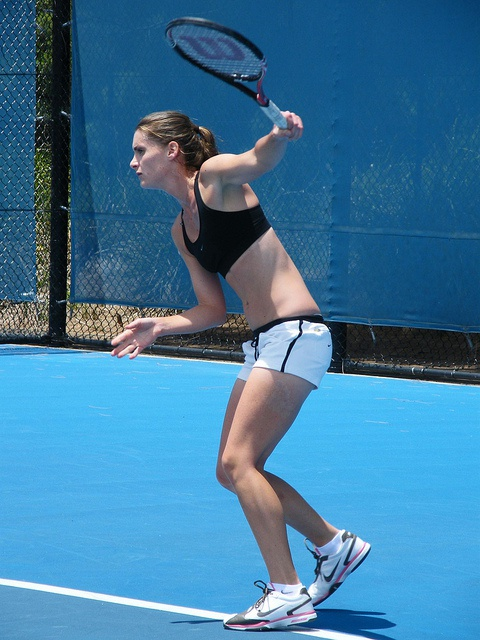Describe the objects in this image and their specific colors. I can see people in gray, black, lightblue, and tan tones and tennis racket in gray, blue, black, and navy tones in this image. 